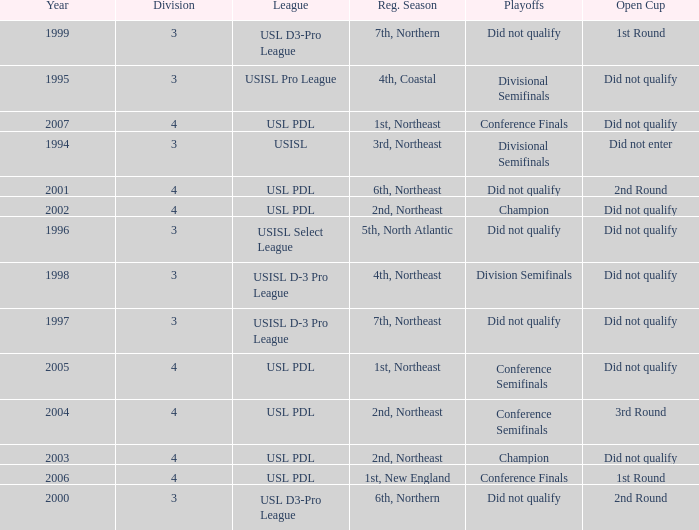Would you mind parsing the complete table? {'header': ['Year', 'Division', 'League', 'Reg. Season', 'Playoffs', 'Open Cup'], 'rows': [['1999', '3', 'USL D3-Pro League', '7th, Northern', 'Did not qualify', '1st Round'], ['1995', '3', 'USISL Pro League', '4th, Coastal', 'Divisional Semifinals', 'Did not qualify'], ['2007', '4', 'USL PDL', '1st, Northeast', 'Conference Finals', 'Did not qualify'], ['1994', '3', 'USISL', '3rd, Northeast', 'Divisional Semifinals', 'Did not enter'], ['2001', '4', 'USL PDL', '6th, Northeast', 'Did not qualify', '2nd Round'], ['2002', '4', 'USL PDL', '2nd, Northeast', 'Champion', 'Did not qualify'], ['1996', '3', 'USISL Select League', '5th, North Atlantic', 'Did not qualify', 'Did not qualify'], ['1998', '3', 'USISL D-3 Pro League', '4th, Northeast', 'Division Semifinals', 'Did not qualify'], ['1997', '3', 'USISL D-3 Pro League', '7th, Northeast', 'Did not qualify', 'Did not qualify'], ['2005', '4', 'USL PDL', '1st, Northeast', 'Conference Semifinals', 'Did not qualify'], ['2004', '4', 'USL PDL', '2nd, Northeast', 'Conference Semifinals', '3rd Round'], ['2003', '4', 'USL PDL', '2nd, Northeast', 'Champion', 'Did not qualify'], ['2006', '4', 'USL PDL', '1st, New England', 'Conference Finals', '1st Round'], ['2000', '3', 'USL D3-Pro League', '6th, Northern', 'Did not qualify', '2nd Round']]} Name the playoffs for  usisl select league Did not qualify. 